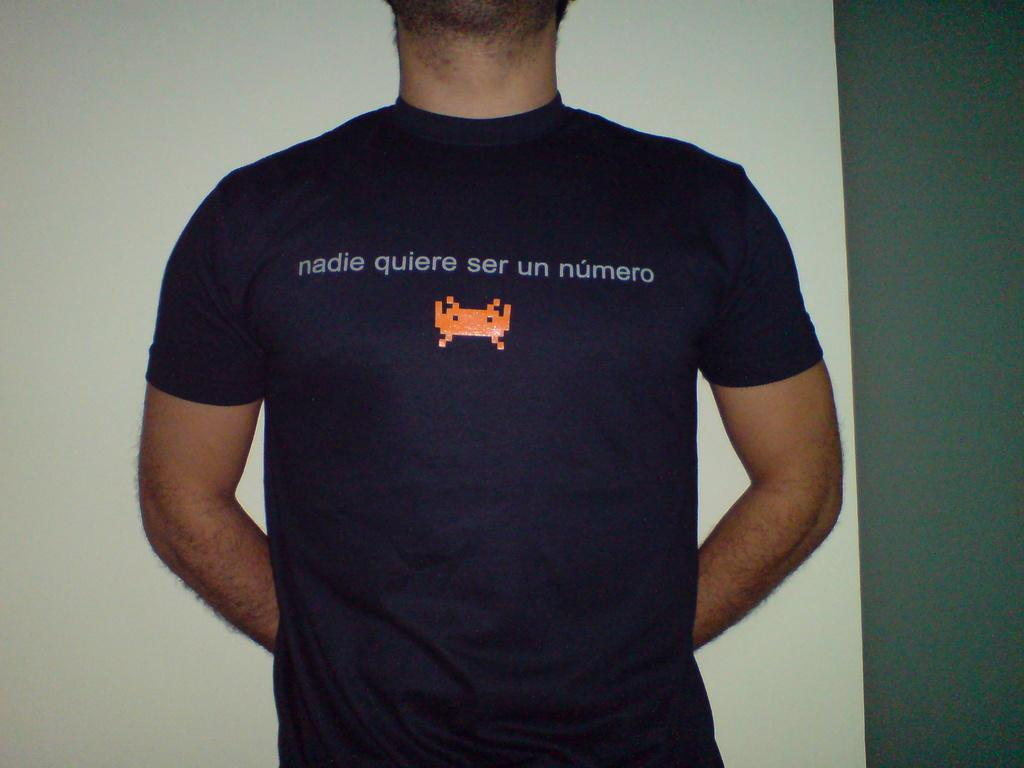What is the main subject of the image? There is a man standing in the image. What is the man wearing in the image? The man is wearing a T-shirt in the image. Are there any words or designs on the T-shirt? Yes, there is text on the T-shirt. What is the color of the background in the image? The background of the image is white. What type of hose is the man using to water the plants in the image? There is no hose or plants present in the image; it only features a man wearing a T-shirt with text on it and a white background. 